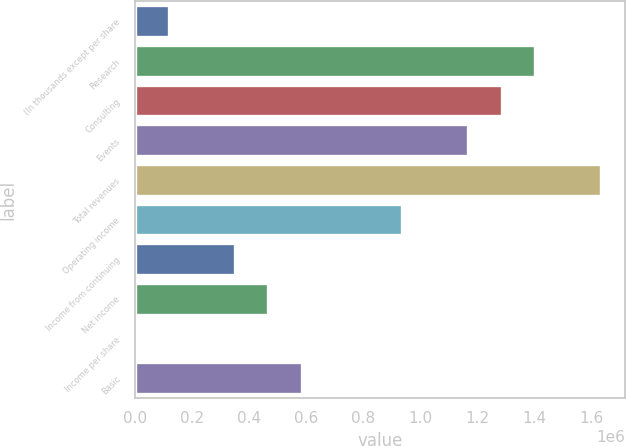Convert chart to OTSL. <chart><loc_0><loc_0><loc_500><loc_500><bar_chart><fcel>(In thousands except per share<fcel>Research<fcel>Consulting<fcel>Events<fcel>Total revenues<fcel>Operating income<fcel>Income from continuing<fcel>Net income<fcel>Income per share<fcel>Basic<nl><fcel>116848<fcel>1.40217e+06<fcel>1.28532e+06<fcel>1.16848e+06<fcel>1.63586e+06<fcel>934780<fcel>350543<fcel>467390<fcel>0.71<fcel>584238<nl></chart> 